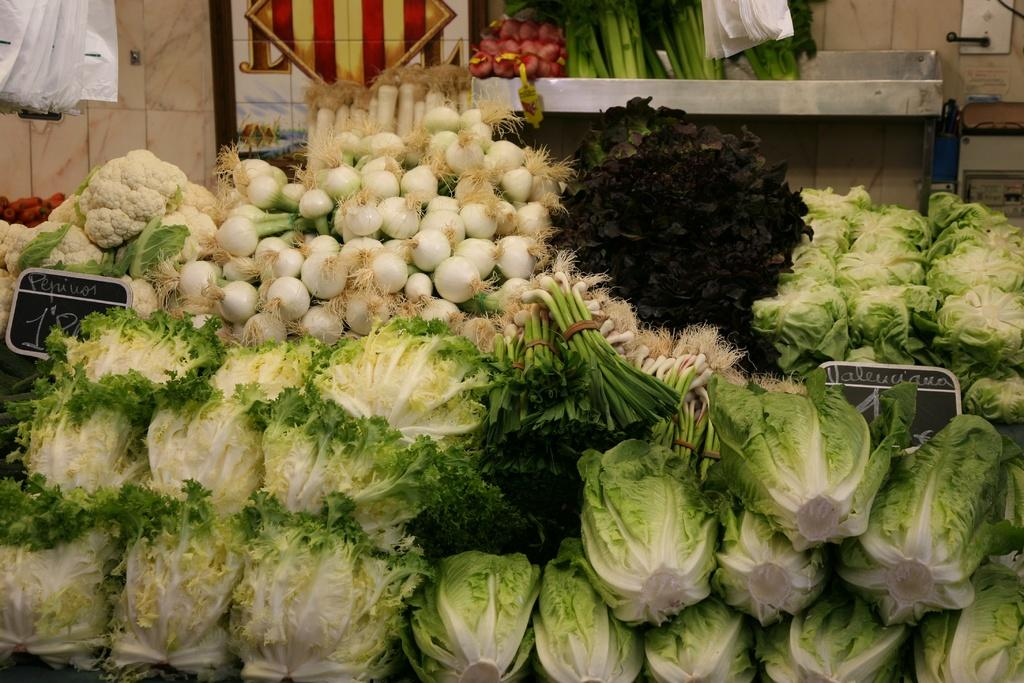What type of food items can be seen in the image? There are vegetables in the image, including cabbage, onions, radish, and leafy vegetables. Can you describe the setting in the background of the image? In the background of the image, there is a stand and covers visible. What is the wall in the background of the image made of? The facts provided do not specify the material of the wall. What advice is the dinosaur giving to the vegetables in the image? There are no dinosaurs present in the image, so no advice can be given. What type of cake is being served with the vegetables in the image? There is no cake present in the image; it only features vegetables and the background setting. 